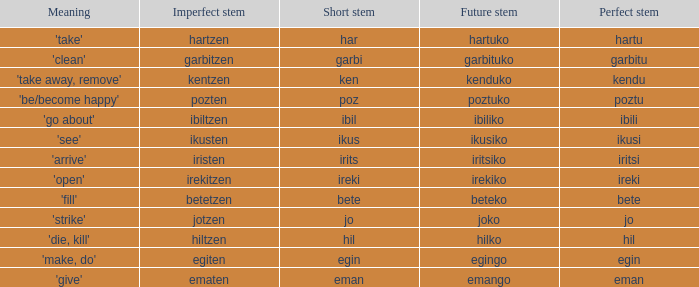What is the perfect stem for pozten? Poztu. 